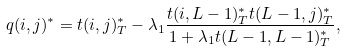<formula> <loc_0><loc_0><loc_500><loc_500>q ( i , j ) ^ { * } = t ( i , j ) ^ { * } _ { T } - \lambda _ { 1 } \frac { t ( i , L - 1 ) ^ { * } _ { T } t ( L - 1 , j ) ^ { * } _ { T } } { 1 + \lambda _ { 1 } t ( L - 1 , L - 1 ) ^ { * } _ { T } } ,</formula> 